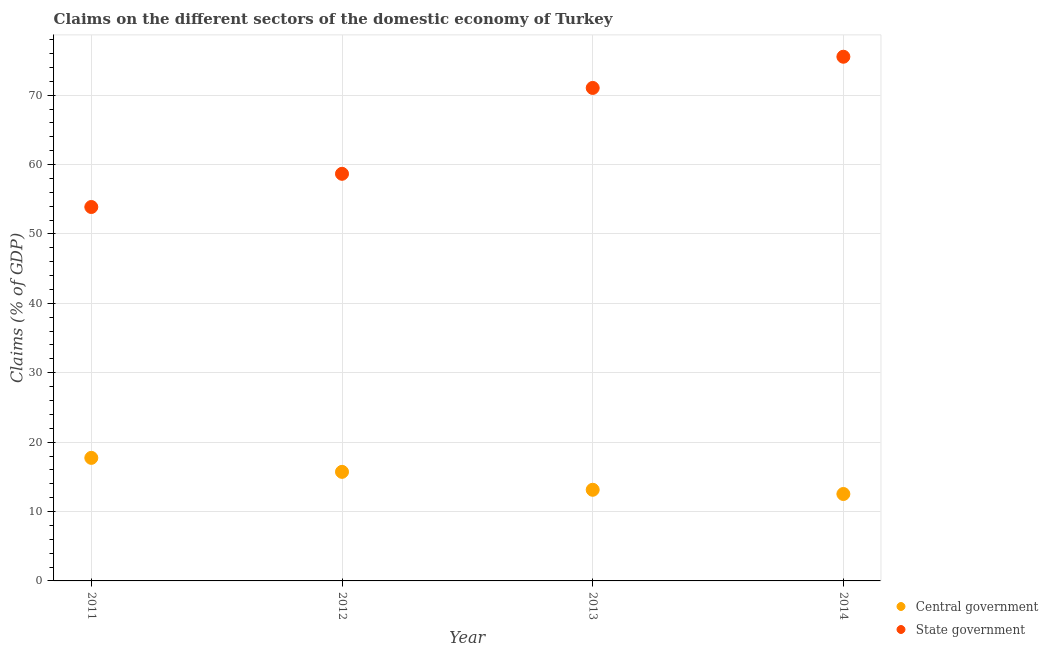How many different coloured dotlines are there?
Your answer should be compact. 2. What is the claims on central government in 2014?
Your response must be concise. 12.53. Across all years, what is the maximum claims on state government?
Your answer should be compact. 75.54. Across all years, what is the minimum claims on state government?
Your response must be concise. 53.89. What is the total claims on central government in the graph?
Give a very brief answer. 59.11. What is the difference between the claims on state government in 2011 and that in 2013?
Give a very brief answer. -17.16. What is the difference between the claims on central government in 2012 and the claims on state government in 2013?
Keep it short and to the point. -55.33. What is the average claims on central government per year?
Your answer should be compact. 14.78. In the year 2013, what is the difference between the claims on state government and claims on central government?
Your answer should be compact. 57.91. In how many years, is the claims on state government greater than 26 %?
Make the answer very short. 4. What is the ratio of the claims on central government in 2011 to that in 2013?
Keep it short and to the point. 1.35. What is the difference between the highest and the second highest claims on central government?
Ensure brevity in your answer.  2.02. What is the difference between the highest and the lowest claims on state government?
Your answer should be compact. 21.65. In how many years, is the claims on state government greater than the average claims on state government taken over all years?
Offer a terse response. 2. Is the sum of the claims on central government in 2011 and 2013 greater than the maximum claims on state government across all years?
Your response must be concise. No. Is the claims on state government strictly less than the claims on central government over the years?
Make the answer very short. No. What is the difference between two consecutive major ticks on the Y-axis?
Provide a short and direct response. 10. Are the values on the major ticks of Y-axis written in scientific E-notation?
Provide a succinct answer. No. Does the graph contain any zero values?
Offer a very short reply. No. Where does the legend appear in the graph?
Your response must be concise. Bottom right. What is the title of the graph?
Offer a terse response. Claims on the different sectors of the domestic economy of Turkey. What is the label or title of the X-axis?
Keep it short and to the point. Year. What is the label or title of the Y-axis?
Offer a very short reply. Claims (% of GDP). What is the Claims (% of GDP) of Central government in 2011?
Your answer should be compact. 17.73. What is the Claims (% of GDP) in State government in 2011?
Provide a short and direct response. 53.89. What is the Claims (% of GDP) in Central government in 2012?
Ensure brevity in your answer.  15.72. What is the Claims (% of GDP) in State government in 2012?
Your answer should be compact. 58.67. What is the Claims (% of GDP) of Central government in 2013?
Make the answer very short. 13.13. What is the Claims (% of GDP) of State government in 2013?
Give a very brief answer. 71.05. What is the Claims (% of GDP) in Central government in 2014?
Make the answer very short. 12.53. What is the Claims (% of GDP) in State government in 2014?
Provide a short and direct response. 75.54. Across all years, what is the maximum Claims (% of GDP) in Central government?
Your response must be concise. 17.73. Across all years, what is the maximum Claims (% of GDP) of State government?
Provide a succinct answer. 75.54. Across all years, what is the minimum Claims (% of GDP) of Central government?
Offer a terse response. 12.53. Across all years, what is the minimum Claims (% of GDP) of State government?
Your response must be concise. 53.89. What is the total Claims (% of GDP) in Central government in the graph?
Ensure brevity in your answer.  59.11. What is the total Claims (% of GDP) of State government in the graph?
Offer a terse response. 259.15. What is the difference between the Claims (% of GDP) in Central government in 2011 and that in 2012?
Ensure brevity in your answer.  2.02. What is the difference between the Claims (% of GDP) of State government in 2011 and that in 2012?
Your response must be concise. -4.78. What is the difference between the Claims (% of GDP) of Central government in 2011 and that in 2013?
Provide a short and direct response. 4.6. What is the difference between the Claims (% of GDP) of State government in 2011 and that in 2013?
Keep it short and to the point. -17.16. What is the difference between the Claims (% of GDP) in Central government in 2011 and that in 2014?
Keep it short and to the point. 5.21. What is the difference between the Claims (% of GDP) in State government in 2011 and that in 2014?
Make the answer very short. -21.65. What is the difference between the Claims (% of GDP) in Central government in 2012 and that in 2013?
Make the answer very short. 2.58. What is the difference between the Claims (% of GDP) of State government in 2012 and that in 2013?
Your response must be concise. -12.38. What is the difference between the Claims (% of GDP) in Central government in 2012 and that in 2014?
Provide a short and direct response. 3.19. What is the difference between the Claims (% of GDP) in State government in 2012 and that in 2014?
Offer a very short reply. -16.87. What is the difference between the Claims (% of GDP) of Central government in 2013 and that in 2014?
Keep it short and to the point. 0.61. What is the difference between the Claims (% of GDP) of State government in 2013 and that in 2014?
Your answer should be very brief. -4.5. What is the difference between the Claims (% of GDP) in Central government in 2011 and the Claims (% of GDP) in State government in 2012?
Make the answer very short. -40.94. What is the difference between the Claims (% of GDP) in Central government in 2011 and the Claims (% of GDP) in State government in 2013?
Your answer should be very brief. -53.31. What is the difference between the Claims (% of GDP) of Central government in 2011 and the Claims (% of GDP) of State government in 2014?
Ensure brevity in your answer.  -57.81. What is the difference between the Claims (% of GDP) in Central government in 2012 and the Claims (% of GDP) in State government in 2013?
Offer a very short reply. -55.33. What is the difference between the Claims (% of GDP) in Central government in 2012 and the Claims (% of GDP) in State government in 2014?
Provide a succinct answer. -59.82. What is the difference between the Claims (% of GDP) of Central government in 2013 and the Claims (% of GDP) of State government in 2014?
Give a very brief answer. -62.41. What is the average Claims (% of GDP) of Central government per year?
Give a very brief answer. 14.78. What is the average Claims (% of GDP) in State government per year?
Offer a very short reply. 64.79. In the year 2011, what is the difference between the Claims (% of GDP) in Central government and Claims (% of GDP) in State government?
Ensure brevity in your answer.  -36.15. In the year 2012, what is the difference between the Claims (% of GDP) of Central government and Claims (% of GDP) of State government?
Keep it short and to the point. -42.95. In the year 2013, what is the difference between the Claims (% of GDP) of Central government and Claims (% of GDP) of State government?
Provide a succinct answer. -57.91. In the year 2014, what is the difference between the Claims (% of GDP) in Central government and Claims (% of GDP) in State government?
Offer a very short reply. -63.02. What is the ratio of the Claims (% of GDP) in Central government in 2011 to that in 2012?
Make the answer very short. 1.13. What is the ratio of the Claims (% of GDP) in State government in 2011 to that in 2012?
Make the answer very short. 0.92. What is the ratio of the Claims (% of GDP) in Central government in 2011 to that in 2013?
Provide a succinct answer. 1.35. What is the ratio of the Claims (% of GDP) in State government in 2011 to that in 2013?
Keep it short and to the point. 0.76. What is the ratio of the Claims (% of GDP) in Central government in 2011 to that in 2014?
Your answer should be very brief. 1.42. What is the ratio of the Claims (% of GDP) in State government in 2011 to that in 2014?
Offer a very short reply. 0.71. What is the ratio of the Claims (% of GDP) in Central government in 2012 to that in 2013?
Ensure brevity in your answer.  1.2. What is the ratio of the Claims (% of GDP) in State government in 2012 to that in 2013?
Make the answer very short. 0.83. What is the ratio of the Claims (% of GDP) of Central government in 2012 to that in 2014?
Make the answer very short. 1.25. What is the ratio of the Claims (% of GDP) in State government in 2012 to that in 2014?
Make the answer very short. 0.78. What is the ratio of the Claims (% of GDP) in Central government in 2013 to that in 2014?
Make the answer very short. 1.05. What is the ratio of the Claims (% of GDP) in State government in 2013 to that in 2014?
Offer a very short reply. 0.94. What is the difference between the highest and the second highest Claims (% of GDP) of Central government?
Give a very brief answer. 2.02. What is the difference between the highest and the second highest Claims (% of GDP) of State government?
Your answer should be compact. 4.5. What is the difference between the highest and the lowest Claims (% of GDP) of Central government?
Provide a succinct answer. 5.21. What is the difference between the highest and the lowest Claims (% of GDP) of State government?
Provide a short and direct response. 21.65. 